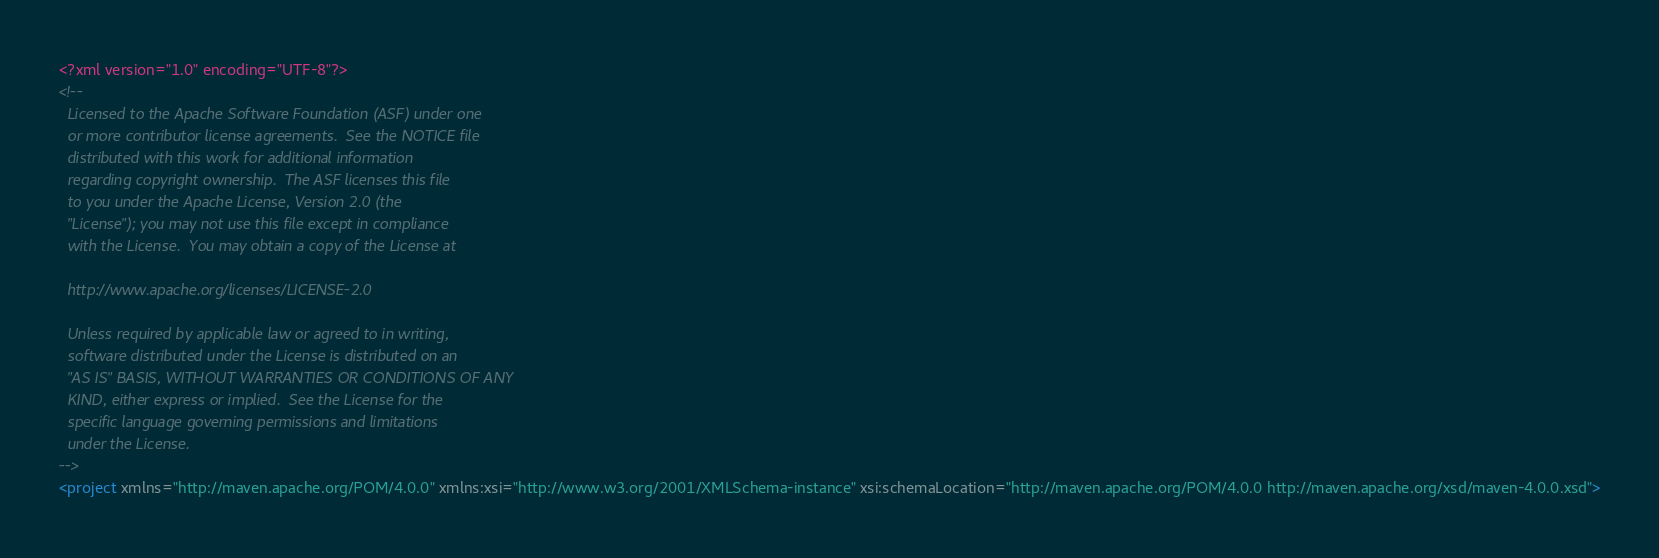<code> <loc_0><loc_0><loc_500><loc_500><_XML_><?xml version="1.0" encoding="UTF-8"?>
<!--
  Licensed to the Apache Software Foundation (ASF) under one
  or more contributor license agreements.  See the NOTICE file
  distributed with this work for additional information
  regarding copyright ownership.  The ASF licenses this file
  to you under the Apache License, Version 2.0 (the
  "License"); you may not use this file except in compliance
  with the License.  You may obtain a copy of the License at

  http://www.apache.org/licenses/LICENSE-2.0

  Unless required by applicable law or agreed to in writing,
  software distributed under the License is distributed on an
  "AS IS" BASIS, WITHOUT WARRANTIES OR CONDITIONS OF ANY
  KIND, either express or implied.  See the License for the
  specific language governing permissions and limitations
  under the License.
-->
<project xmlns="http://maven.apache.org/POM/4.0.0" xmlns:xsi="http://www.w3.org/2001/XMLSchema-instance" xsi:schemaLocation="http://maven.apache.org/POM/4.0.0 http://maven.apache.org/xsd/maven-4.0.0.xsd"></code> 